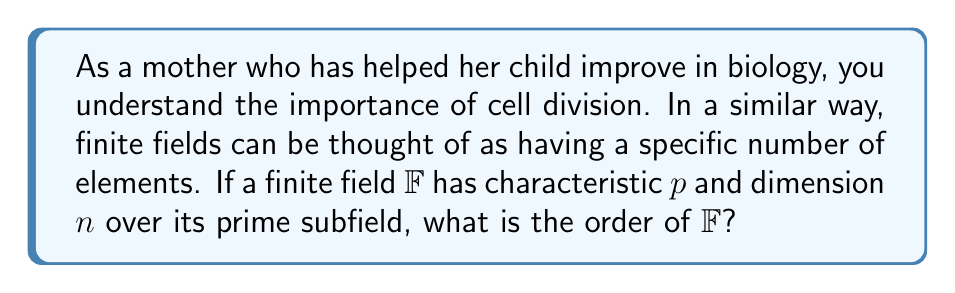Show me your answer to this math problem. Let's approach this step-by-step:

1) In a finite field $\mathbb{F}$, the characteristic $p$ is always a prime number. This is similar to how the basic unit of life is a cell.

2) The prime subfield of $\mathbb{F}$ is isomorphic to $\mathbb{F}_p$, which has $p$ elements.

3) The dimension $n$ represents how many "copies" of the prime subfield we need to construct $\mathbb{F}$. This is analogous to how many cells combine to form a complex organism.

4) Each element of $\mathbb{F}$ can be represented as an $n$-tuple of elements from $\mathbb{F}_p$.

5) For each position in this $n$-tuple, we have $p$ choices (the elements of $\mathbb{F}_p$).

6) Therefore, the total number of elements in $\mathbb{F}$ is the number of possible $n$-tuples, which is:

   $$p \times p \times \cdots \times p \text{ ($n$ times)} = p^n$$

Thus, the order of the finite field $\mathbb{F}$ is $p^n$.
Answer: $p^n$ 